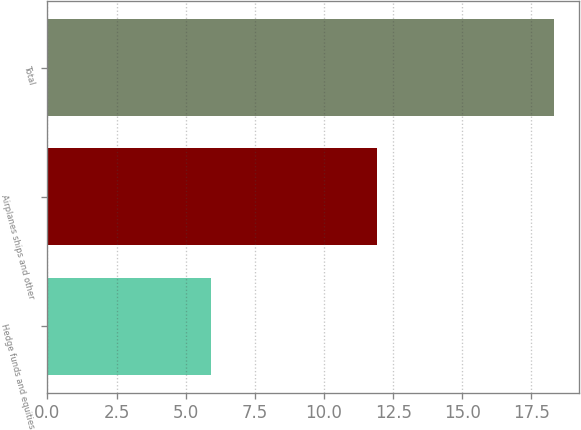Convert chart to OTSL. <chart><loc_0><loc_0><loc_500><loc_500><bar_chart><fcel>Hedge funds and equities<fcel>Airplanes ships and other<fcel>Total<nl><fcel>5.9<fcel>11.9<fcel>18.3<nl></chart> 